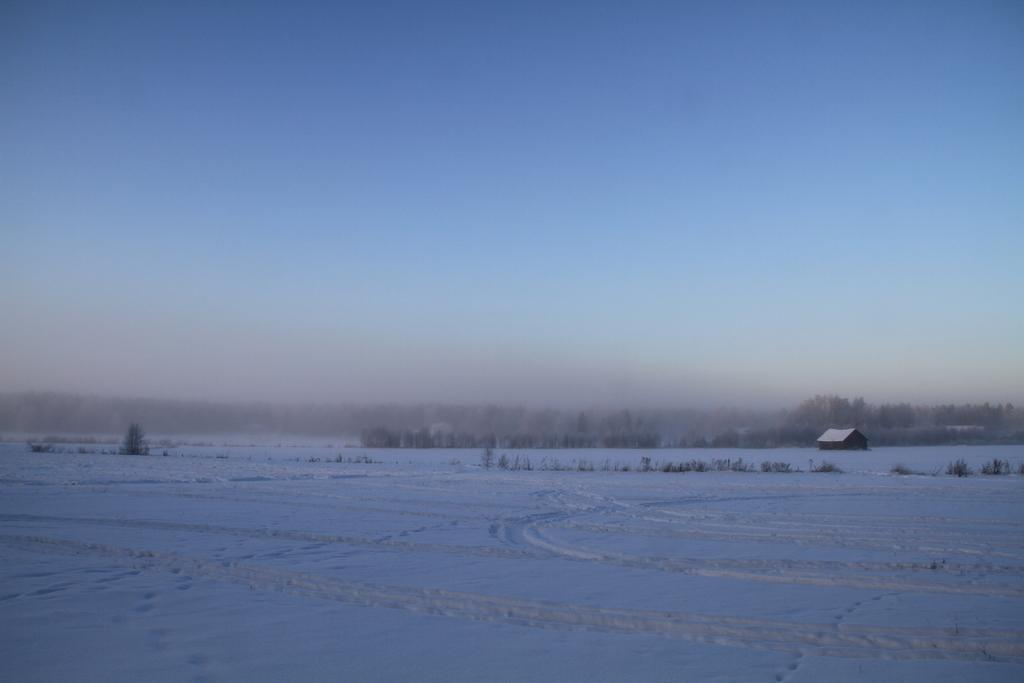What type of weather is depicted in the image? The image contains snow, which suggests cold weather. What type of vegetation is present in the image? There are trees and grass visible in the image. What type of structure can be seen in the image? There is a small house in the image. What is visible in the sky in the image? The sky is visible in the image. What degree does the farmer hold in the image? There is no farmer present in the image, and therefore no degree can be observed. What type of sign is visible in the image? There is no sign visible in the image. 